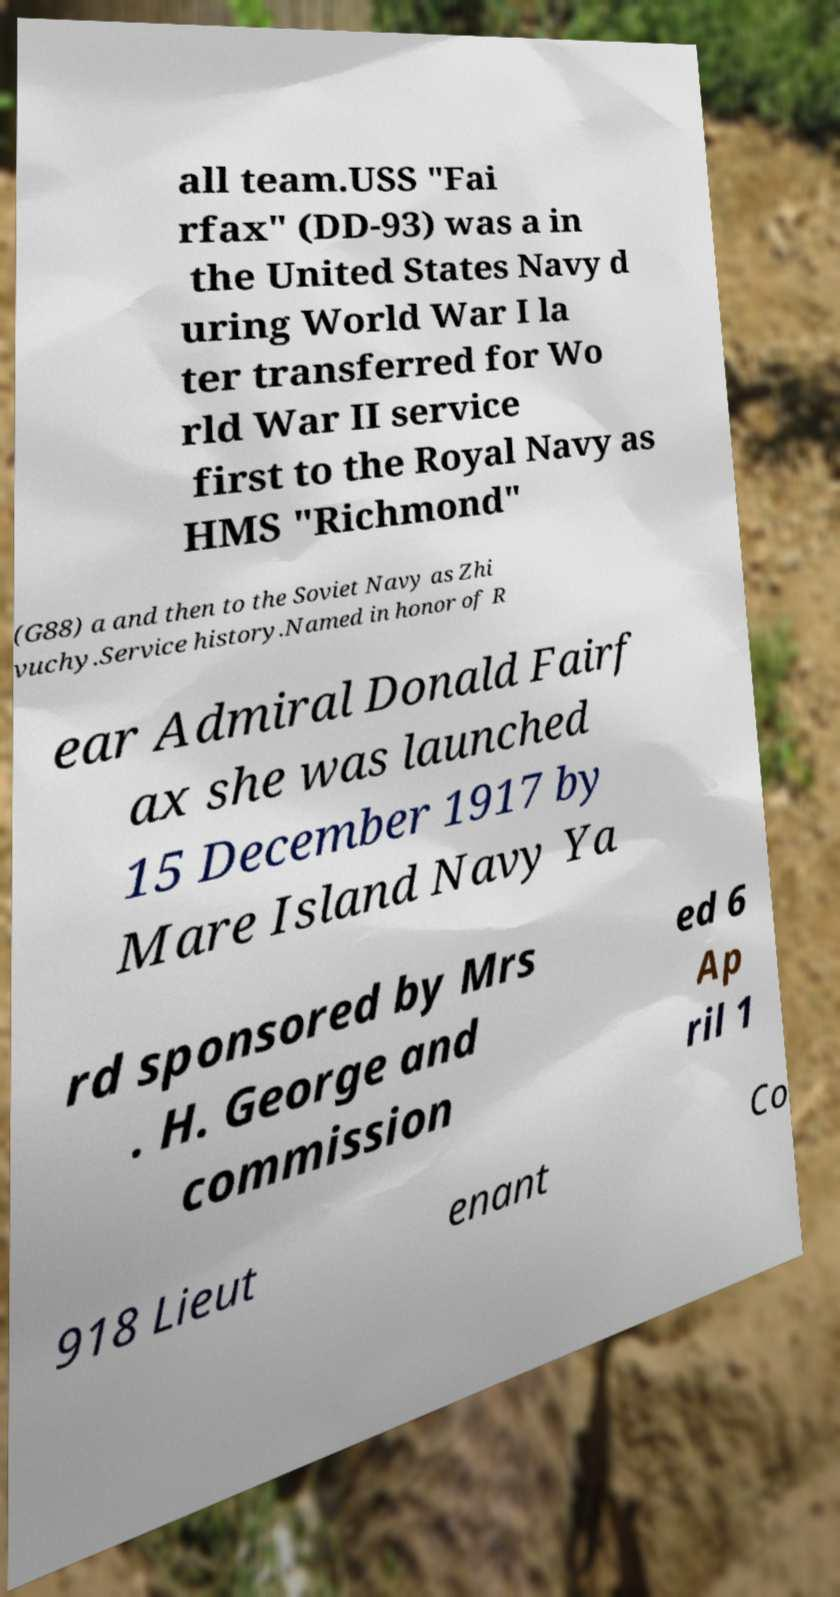Could you assist in decoding the text presented in this image and type it out clearly? all team.USS "Fai rfax" (DD-93) was a in the United States Navy d uring World War I la ter transferred for Wo rld War II service first to the Royal Navy as HMS "Richmond" (G88) a and then to the Soviet Navy as Zhi vuchy.Service history.Named in honor of R ear Admiral Donald Fairf ax she was launched 15 December 1917 by Mare Island Navy Ya rd sponsored by Mrs . H. George and commission ed 6 Ap ril 1 918 Lieut enant Co 